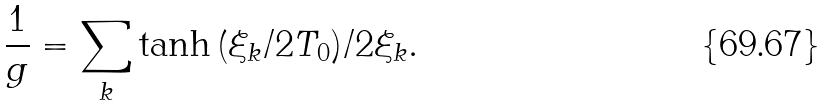<formula> <loc_0><loc_0><loc_500><loc_500>\frac { 1 } { g } = \sum _ { k } \tanh { \left ( \xi _ { k } / 2 T _ { 0 } \right ) } / 2 \xi _ { k } .</formula> 